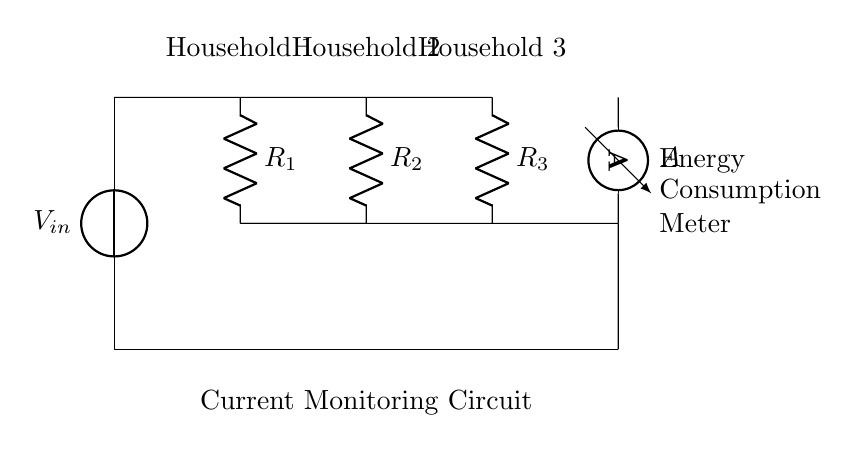What is the total number of households represented in the circuit? The circuit shows three households connected in parallel. Each household is represented by one resistor.
Answer: Three What type of current flow is being measured by the ammeter? The ammeter measures the total current passing through it, which is the sum of the current flowing through each household resistor.
Answer: Total current What is the role of the resistors in this circuit? The resistors represent the electrical loads of each household, influencing current division and allowing energy consumption to be monitored separately for each.
Answer: Electrical loads How are the households connected in this circuit? The households are connected in parallel, meaning the voltage across each household is the same while the current divides among them based on their respective resistances.
Answer: Parallel What happens to the current in Household 1 if its resistance is decreased? If the resistance of Household 1 decreases, more current will flow through it according to the current divider rule, while the total voltage remains constant.
Answer: Increases What is the significance of the ammeter positioned at the end of the circuit? The ammeter measures the total current output from the circuit, providing information on the total energy consumption of all households combined rather than individually.
Answer: Total consumption measurement 